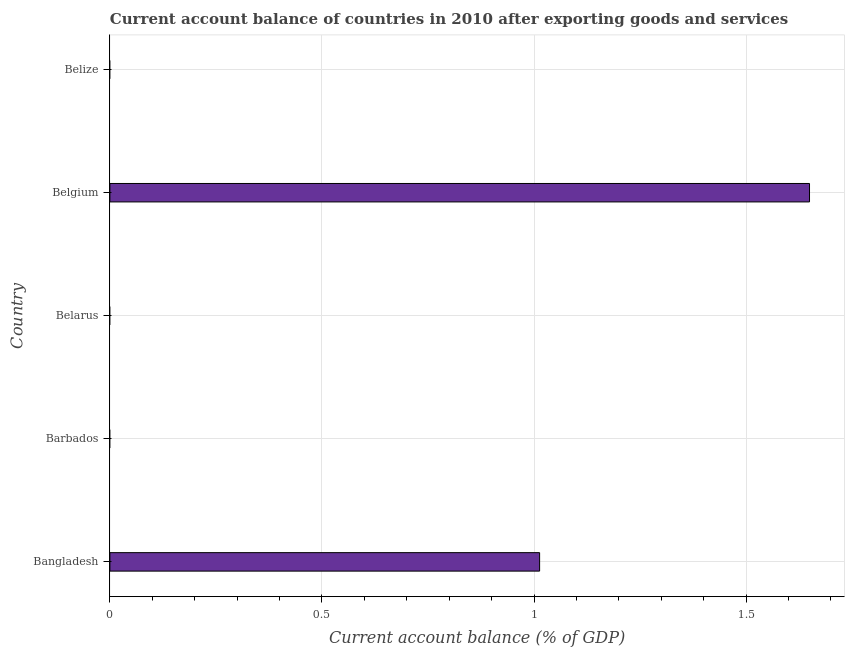Does the graph contain any zero values?
Make the answer very short. Yes. Does the graph contain grids?
Ensure brevity in your answer.  Yes. What is the title of the graph?
Keep it short and to the point. Current account balance of countries in 2010 after exporting goods and services. What is the label or title of the X-axis?
Ensure brevity in your answer.  Current account balance (% of GDP). What is the current account balance in Bangladesh?
Your answer should be very brief. 1.01. Across all countries, what is the maximum current account balance?
Provide a succinct answer. 1.65. What is the sum of the current account balance?
Keep it short and to the point. 2.66. What is the average current account balance per country?
Give a very brief answer. 0.53. In how many countries, is the current account balance greater than 0.3 %?
Your answer should be very brief. 2. What is the difference between the highest and the lowest current account balance?
Ensure brevity in your answer.  1.65. Are all the bars in the graph horizontal?
Your answer should be compact. Yes. How many countries are there in the graph?
Offer a terse response. 5. What is the difference between two consecutive major ticks on the X-axis?
Ensure brevity in your answer.  0.5. Are the values on the major ticks of X-axis written in scientific E-notation?
Provide a succinct answer. No. What is the Current account balance (% of GDP) of Bangladesh?
Your response must be concise. 1.01. What is the Current account balance (% of GDP) in Belgium?
Your response must be concise. 1.65. What is the difference between the Current account balance (% of GDP) in Bangladesh and Belgium?
Offer a terse response. -0.64. What is the ratio of the Current account balance (% of GDP) in Bangladesh to that in Belgium?
Keep it short and to the point. 0.61. 